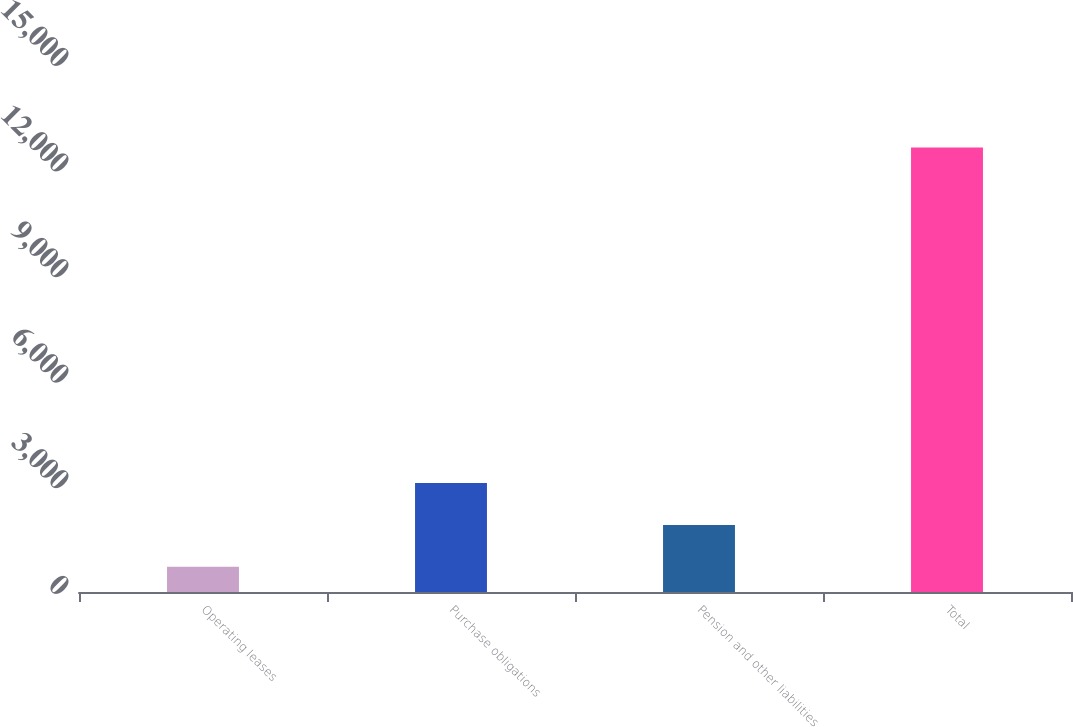Convert chart to OTSL. <chart><loc_0><loc_0><loc_500><loc_500><bar_chart><fcel>Operating leases<fcel>Purchase obligations<fcel>Pension and other liabilities<fcel>Total<nl><fcel>714<fcel>3097.4<fcel>1905.7<fcel>12631<nl></chart> 